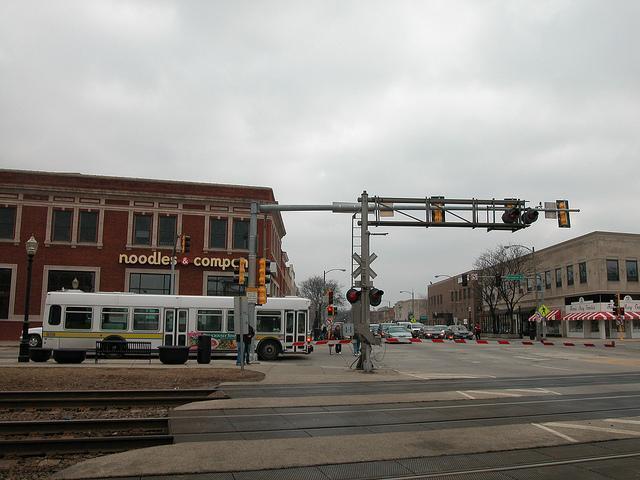What is causing traffic to stop?
Pick the correct solution from the four options below to address the question.
Options: Pedestrians, stalled car, oncoming train, stalled bus. Oncoming train. 